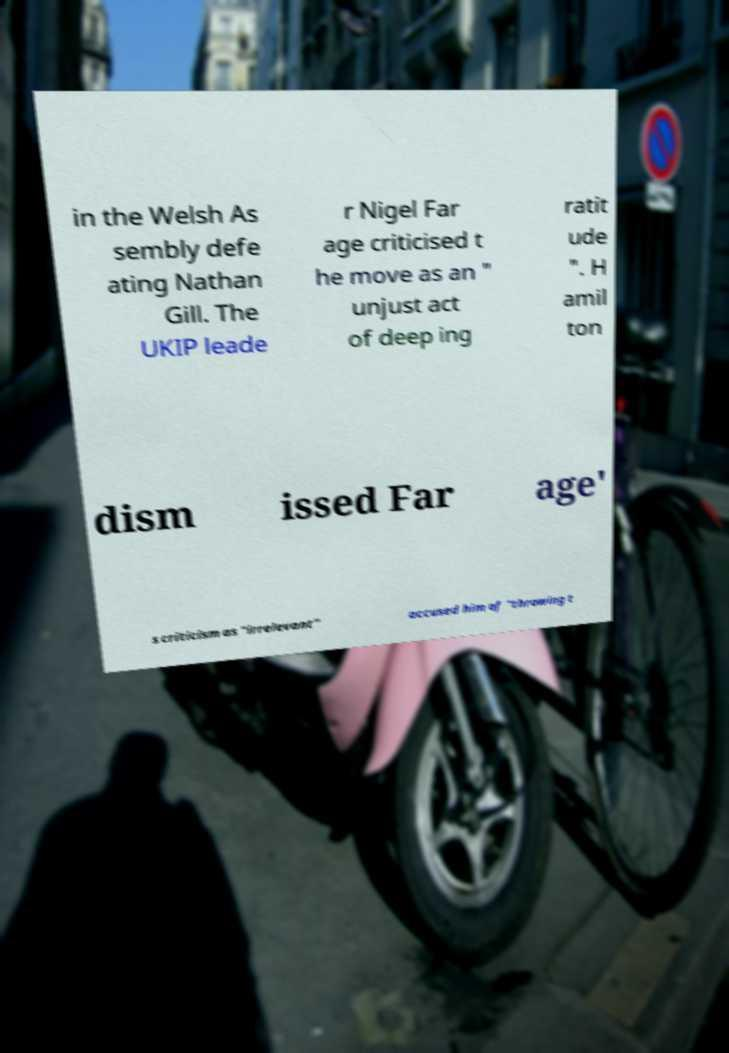Could you extract and type out the text from this image? in the Welsh As sembly defe ating Nathan Gill. The UKIP leade r Nigel Far age criticised t he move as an " unjust act of deep ing ratit ude ". H amil ton dism issed Far age' s criticism as "irrelevant" accused him of "throwing t 